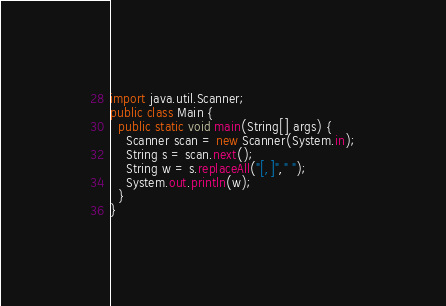<code> <loc_0><loc_0><loc_500><loc_500><_Java_>import java.util.Scanner;
public class Main {
  public static void main(String[] args) {
    Scanner scan = new Scanner(System.in);
    String s = scan.next();
    String w = s.replaceAll("[,]"," ");
    System.out.println(w);
  }
}
</code> 